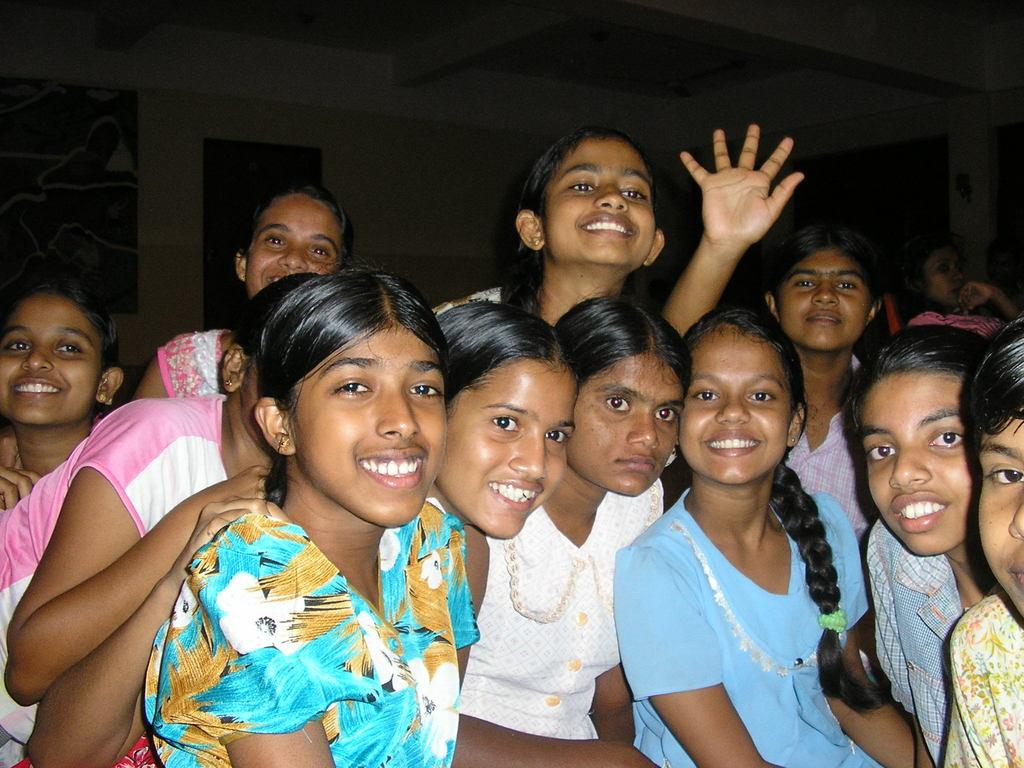What can be seen in the image? There is a group of girls in the image. How are the girls in the image feeling? The girls are smiling in the image. What can be seen in the background of the image? There is a person, a wall, a ceiling, and some objects in the background of the image. What type of fruit is hanging from the ceiling in the image? There is no fruit hanging from the ceiling in the image. What shape is the house in the image? There is no house present in the image. 